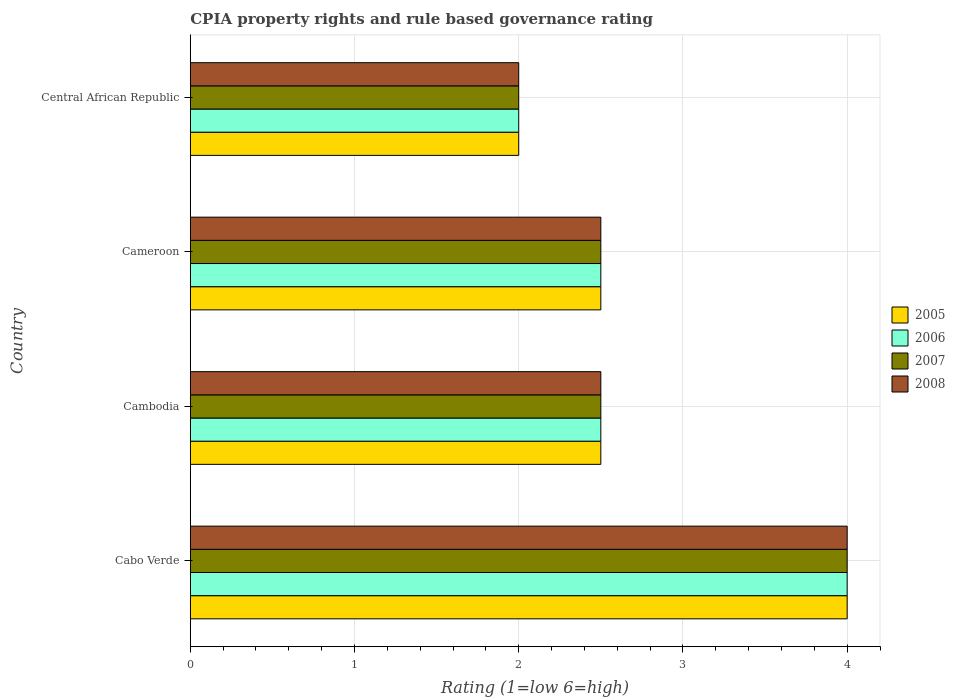How many groups of bars are there?
Give a very brief answer. 4. Are the number of bars per tick equal to the number of legend labels?
Offer a very short reply. Yes. Are the number of bars on each tick of the Y-axis equal?
Offer a very short reply. Yes. How many bars are there on the 2nd tick from the top?
Provide a succinct answer. 4. What is the label of the 2nd group of bars from the top?
Provide a short and direct response. Cameroon. In how many cases, is the number of bars for a given country not equal to the number of legend labels?
Ensure brevity in your answer.  0. What is the CPIA rating in 2008 in Cameroon?
Give a very brief answer. 2.5. Across all countries, what is the minimum CPIA rating in 2007?
Your answer should be compact. 2. In which country was the CPIA rating in 2006 maximum?
Provide a short and direct response. Cabo Verde. In which country was the CPIA rating in 2008 minimum?
Give a very brief answer. Central African Republic. What is the difference between the CPIA rating in 2007 in Cabo Verde and the CPIA rating in 2006 in Cambodia?
Provide a succinct answer. 1.5. What is the average CPIA rating in 2007 per country?
Offer a very short reply. 2.75. What is the ratio of the CPIA rating in 2006 in Cambodia to that in Cameroon?
Ensure brevity in your answer.  1. Is the difference between the CPIA rating in 2005 in Cambodia and Cameroon greater than the difference between the CPIA rating in 2006 in Cambodia and Cameroon?
Ensure brevity in your answer.  No. What is the difference between the highest and the lowest CPIA rating in 2008?
Your response must be concise. 2. What does the 1st bar from the top in Cameroon represents?
Give a very brief answer. 2008. Is it the case that in every country, the sum of the CPIA rating in 2005 and CPIA rating in 2006 is greater than the CPIA rating in 2007?
Give a very brief answer. Yes. How many bars are there?
Keep it short and to the point. 16. Are all the bars in the graph horizontal?
Provide a succinct answer. Yes. How many countries are there in the graph?
Provide a short and direct response. 4. What is the difference between two consecutive major ticks on the X-axis?
Give a very brief answer. 1. Are the values on the major ticks of X-axis written in scientific E-notation?
Your answer should be very brief. No. Does the graph contain any zero values?
Provide a succinct answer. No. Where does the legend appear in the graph?
Give a very brief answer. Center right. How are the legend labels stacked?
Offer a terse response. Vertical. What is the title of the graph?
Offer a very short reply. CPIA property rights and rule based governance rating. What is the Rating (1=low 6=high) of 2005 in Cabo Verde?
Ensure brevity in your answer.  4. What is the Rating (1=low 6=high) in 2008 in Cabo Verde?
Keep it short and to the point. 4. What is the Rating (1=low 6=high) of 2005 in Cambodia?
Your answer should be very brief. 2.5. What is the Rating (1=low 6=high) of 2007 in Cambodia?
Ensure brevity in your answer.  2.5. What is the Rating (1=low 6=high) in 2005 in Cameroon?
Offer a very short reply. 2.5. What is the Rating (1=low 6=high) in 2008 in Cameroon?
Provide a succinct answer. 2.5. What is the Rating (1=low 6=high) of 2006 in Central African Republic?
Offer a very short reply. 2. What is the Rating (1=low 6=high) of 2008 in Central African Republic?
Provide a succinct answer. 2. Across all countries, what is the maximum Rating (1=low 6=high) of 2005?
Make the answer very short. 4. Across all countries, what is the maximum Rating (1=low 6=high) of 2006?
Offer a very short reply. 4. Across all countries, what is the maximum Rating (1=low 6=high) of 2008?
Keep it short and to the point. 4. Across all countries, what is the minimum Rating (1=low 6=high) in 2006?
Your answer should be compact. 2. Across all countries, what is the minimum Rating (1=low 6=high) in 2007?
Your answer should be compact. 2. Across all countries, what is the minimum Rating (1=low 6=high) in 2008?
Your answer should be compact. 2. What is the total Rating (1=low 6=high) in 2005 in the graph?
Ensure brevity in your answer.  11. What is the total Rating (1=low 6=high) of 2006 in the graph?
Your answer should be very brief. 11. What is the total Rating (1=low 6=high) in 2007 in the graph?
Make the answer very short. 11. What is the difference between the Rating (1=low 6=high) in 2005 in Cabo Verde and that in Cambodia?
Offer a terse response. 1.5. What is the difference between the Rating (1=low 6=high) of 2005 in Cabo Verde and that in Cameroon?
Give a very brief answer. 1.5. What is the difference between the Rating (1=low 6=high) in 2006 in Cabo Verde and that in Cameroon?
Your answer should be very brief. 1.5. What is the difference between the Rating (1=low 6=high) in 2007 in Cabo Verde and that in Cameroon?
Make the answer very short. 1.5. What is the difference between the Rating (1=low 6=high) in 2006 in Cabo Verde and that in Central African Republic?
Offer a terse response. 2. What is the difference between the Rating (1=low 6=high) of 2007 in Cabo Verde and that in Central African Republic?
Provide a succinct answer. 2. What is the difference between the Rating (1=low 6=high) of 2005 in Cambodia and that in Cameroon?
Provide a succinct answer. 0. What is the difference between the Rating (1=low 6=high) in 2007 in Cambodia and that in Cameroon?
Your response must be concise. 0. What is the difference between the Rating (1=low 6=high) of 2008 in Cambodia and that in Cameroon?
Provide a succinct answer. 0. What is the difference between the Rating (1=low 6=high) in 2005 in Cambodia and that in Central African Republic?
Offer a terse response. 0.5. What is the difference between the Rating (1=low 6=high) of 2006 in Cambodia and that in Central African Republic?
Make the answer very short. 0.5. What is the difference between the Rating (1=low 6=high) of 2007 in Cambodia and that in Central African Republic?
Keep it short and to the point. 0.5. What is the difference between the Rating (1=low 6=high) in 2008 in Cambodia and that in Central African Republic?
Your response must be concise. 0.5. What is the difference between the Rating (1=low 6=high) in 2005 in Cameroon and that in Central African Republic?
Your answer should be very brief. 0.5. What is the difference between the Rating (1=low 6=high) in 2007 in Cameroon and that in Central African Republic?
Ensure brevity in your answer.  0.5. What is the difference between the Rating (1=low 6=high) in 2008 in Cameroon and that in Central African Republic?
Your answer should be compact. 0.5. What is the difference between the Rating (1=low 6=high) of 2005 in Cabo Verde and the Rating (1=low 6=high) of 2006 in Cambodia?
Provide a short and direct response. 1.5. What is the difference between the Rating (1=low 6=high) of 2005 in Cabo Verde and the Rating (1=low 6=high) of 2007 in Cambodia?
Your answer should be very brief. 1.5. What is the difference between the Rating (1=low 6=high) of 2005 in Cabo Verde and the Rating (1=low 6=high) of 2008 in Cambodia?
Provide a succinct answer. 1.5. What is the difference between the Rating (1=low 6=high) of 2006 in Cabo Verde and the Rating (1=low 6=high) of 2007 in Cambodia?
Make the answer very short. 1.5. What is the difference between the Rating (1=low 6=high) in 2005 in Cabo Verde and the Rating (1=low 6=high) in 2007 in Cameroon?
Your answer should be compact. 1.5. What is the difference between the Rating (1=low 6=high) in 2006 in Cabo Verde and the Rating (1=low 6=high) in 2008 in Cameroon?
Keep it short and to the point. 1.5. What is the difference between the Rating (1=low 6=high) in 2005 in Cabo Verde and the Rating (1=low 6=high) in 2008 in Central African Republic?
Your response must be concise. 2. What is the difference between the Rating (1=low 6=high) in 2006 in Cabo Verde and the Rating (1=low 6=high) in 2007 in Central African Republic?
Your answer should be very brief. 2. What is the difference between the Rating (1=low 6=high) of 2007 in Cabo Verde and the Rating (1=low 6=high) of 2008 in Central African Republic?
Your answer should be very brief. 2. What is the difference between the Rating (1=low 6=high) in 2005 in Cambodia and the Rating (1=low 6=high) in 2006 in Cameroon?
Your answer should be compact. 0. What is the difference between the Rating (1=low 6=high) in 2005 in Cambodia and the Rating (1=low 6=high) in 2007 in Cameroon?
Make the answer very short. 0. What is the difference between the Rating (1=low 6=high) in 2006 in Cambodia and the Rating (1=low 6=high) in 2008 in Cameroon?
Offer a terse response. 0. What is the difference between the Rating (1=low 6=high) in 2005 in Cambodia and the Rating (1=low 6=high) in 2006 in Central African Republic?
Your answer should be compact. 0.5. What is the difference between the Rating (1=low 6=high) in 2005 in Cambodia and the Rating (1=low 6=high) in 2007 in Central African Republic?
Your answer should be very brief. 0.5. What is the difference between the Rating (1=low 6=high) of 2005 in Cambodia and the Rating (1=low 6=high) of 2008 in Central African Republic?
Keep it short and to the point. 0.5. What is the difference between the Rating (1=low 6=high) in 2006 in Cambodia and the Rating (1=low 6=high) in 2007 in Central African Republic?
Offer a very short reply. 0.5. What is the difference between the Rating (1=low 6=high) in 2006 in Cambodia and the Rating (1=low 6=high) in 2008 in Central African Republic?
Keep it short and to the point. 0.5. What is the difference between the Rating (1=low 6=high) of 2007 in Cambodia and the Rating (1=low 6=high) of 2008 in Central African Republic?
Make the answer very short. 0.5. What is the difference between the Rating (1=low 6=high) of 2005 in Cameroon and the Rating (1=low 6=high) of 2006 in Central African Republic?
Offer a very short reply. 0.5. What is the difference between the Rating (1=low 6=high) in 2005 in Cameroon and the Rating (1=low 6=high) in 2007 in Central African Republic?
Provide a succinct answer. 0.5. What is the difference between the Rating (1=low 6=high) of 2005 in Cameroon and the Rating (1=low 6=high) of 2008 in Central African Republic?
Your answer should be compact. 0.5. What is the difference between the Rating (1=low 6=high) of 2006 in Cameroon and the Rating (1=low 6=high) of 2008 in Central African Republic?
Ensure brevity in your answer.  0.5. What is the average Rating (1=low 6=high) in 2005 per country?
Your answer should be very brief. 2.75. What is the average Rating (1=low 6=high) of 2006 per country?
Ensure brevity in your answer.  2.75. What is the average Rating (1=low 6=high) in 2007 per country?
Give a very brief answer. 2.75. What is the average Rating (1=low 6=high) in 2008 per country?
Provide a succinct answer. 2.75. What is the difference between the Rating (1=low 6=high) in 2006 and Rating (1=low 6=high) in 2007 in Cabo Verde?
Ensure brevity in your answer.  0. What is the difference between the Rating (1=low 6=high) of 2007 and Rating (1=low 6=high) of 2008 in Cabo Verde?
Keep it short and to the point. 0. What is the difference between the Rating (1=low 6=high) of 2005 and Rating (1=low 6=high) of 2006 in Cambodia?
Ensure brevity in your answer.  0. What is the difference between the Rating (1=low 6=high) of 2006 and Rating (1=low 6=high) of 2008 in Cambodia?
Offer a very short reply. 0. What is the difference between the Rating (1=low 6=high) in 2005 and Rating (1=low 6=high) in 2006 in Cameroon?
Make the answer very short. 0. What is the difference between the Rating (1=low 6=high) in 2005 and Rating (1=low 6=high) in 2008 in Cameroon?
Offer a very short reply. 0. What is the difference between the Rating (1=low 6=high) of 2006 and Rating (1=low 6=high) of 2007 in Cameroon?
Offer a terse response. 0. What is the difference between the Rating (1=low 6=high) in 2006 and Rating (1=low 6=high) in 2008 in Cameroon?
Offer a terse response. 0. What is the difference between the Rating (1=low 6=high) in 2005 and Rating (1=low 6=high) in 2006 in Central African Republic?
Offer a very short reply. 0. What is the difference between the Rating (1=low 6=high) of 2005 and Rating (1=low 6=high) of 2007 in Central African Republic?
Your response must be concise. 0. What is the difference between the Rating (1=low 6=high) in 2006 and Rating (1=low 6=high) in 2007 in Central African Republic?
Ensure brevity in your answer.  0. What is the difference between the Rating (1=low 6=high) of 2006 and Rating (1=low 6=high) of 2008 in Central African Republic?
Your answer should be very brief. 0. What is the difference between the Rating (1=low 6=high) in 2007 and Rating (1=low 6=high) in 2008 in Central African Republic?
Your answer should be compact. 0. What is the ratio of the Rating (1=low 6=high) of 2005 in Cabo Verde to that in Cambodia?
Give a very brief answer. 1.6. What is the ratio of the Rating (1=low 6=high) of 2006 in Cabo Verde to that in Cambodia?
Your answer should be compact. 1.6. What is the ratio of the Rating (1=low 6=high) of 2007 in Cabo Verde to that in Cambodia?
Give a very brief answer. 1.6. What is the ratio of the Rating (1=low 6=high) in 2005 in Cabo Verde to that in Cameroon?
Your answer should be very brief. 1.6. What is the ratio of the Rating (1=low 6=high) in 2007 in Cabo Verde to that in Cameroon?
Your answer should be compact. 1.6. What is the ratio of the Rating (1=low 6=high) in 2008 in Cabo Verde to that in Cameroon?
Your answer should be very brief. 1.6. What is the ratio of the Rating (1=low 6=high) in 2005 in Cabo Verde to that in Central African Republic?
Provide a succinct answer. 2. What is the ratio of the Rating (1=low 6=high) of 2005 in Cambodia to that in Cameroon?
Your response must be concise. 1. What is the ratio of the Rating (1=low 6=high) in 2006 in Cambodia to that in Cameroon?
Provide a succinct answer. 1. What is the ratio of the Rating (1=low 6=high) in 2007 in Cambodia to that in Cameroon?
Offer a very short reply. 1. What is the difference between the highest and the second highest Rating (1=low 6=high) in 2005?
Give a very brief answer. 1.5. What is the difference between the highest and the second highest Rating (1=low 6=high) of 2006?
Make the answer very short. 1.5. What is the difference between the highest and the second highest Rating (1=low 6=high) of 2007?
Make the answer very short. 1.5. What is the difference between the highest and the second highest Rating (1=low 6=high) of 2008?
Your answer should be very brief. 1.5. What is the difference between the highest and the lowest Rating (1=low 6=high) of 2005?
Your answer should be compact. 2. What is the difference between the highest and the lowest Rating (1=low 6=high) of 2007?
Provide a short and direct response. 2. 